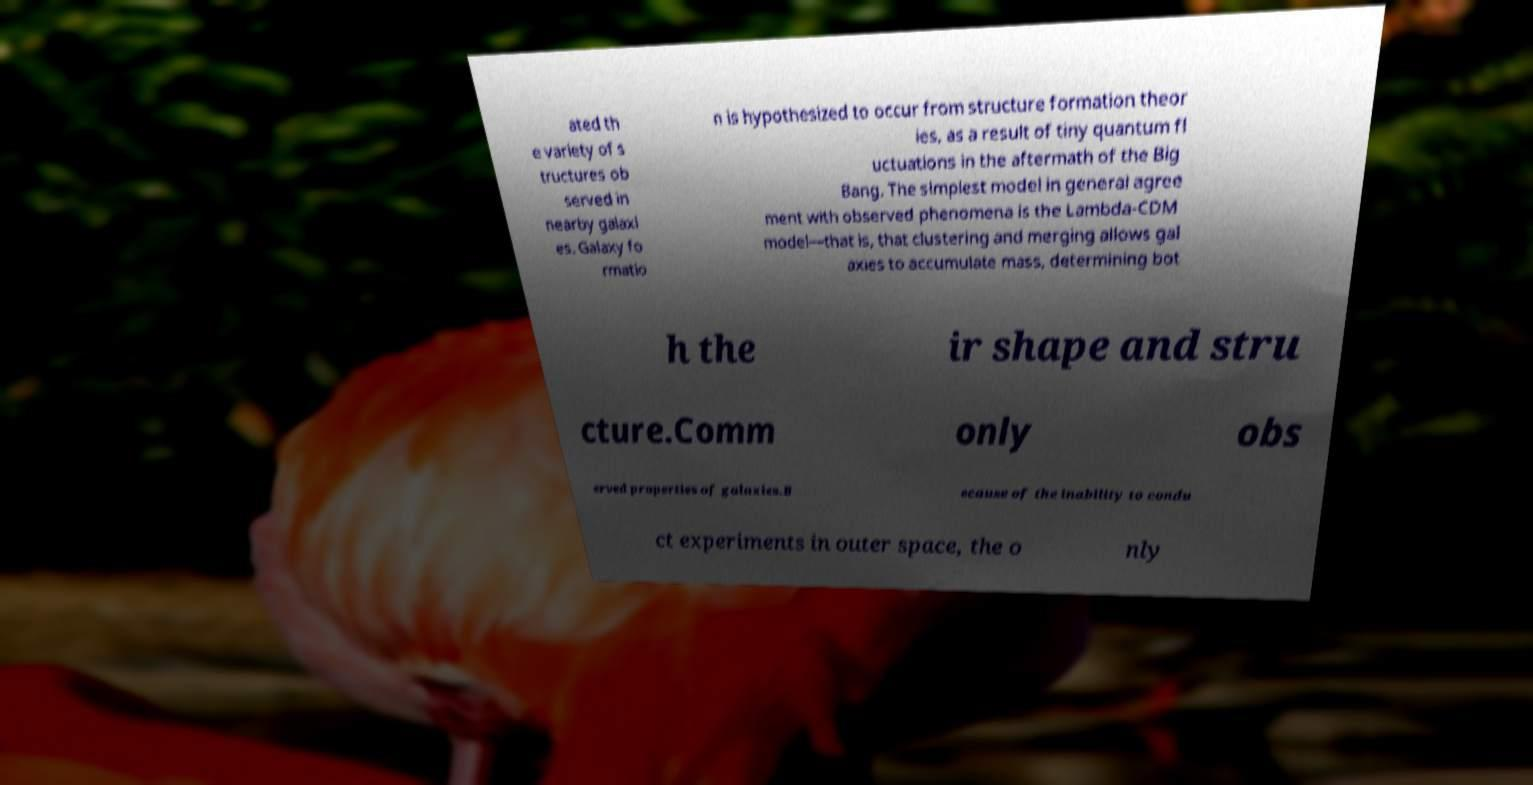There's text embedded in this image that I need extracted. Can you transcribe it verbatim? ated th e variety of s tructures ob served in nearby galaxi es. Galaxy fo rmatio n is hypothesized to occur from structure formation theor ies, as a result of tiny quantum fl uctuations in the aftermath of the Big Bang. The simplest model in general agree ment with observed phenomena is the Lambda-CDM model—that is, that clustering and merging allows gal axies to accumulate mass, determining bot h the ir shape and stru cture.Comm only obs erved properties of galaxies.B ecause of the inability to condu ct experiments in outer space, the o nly 